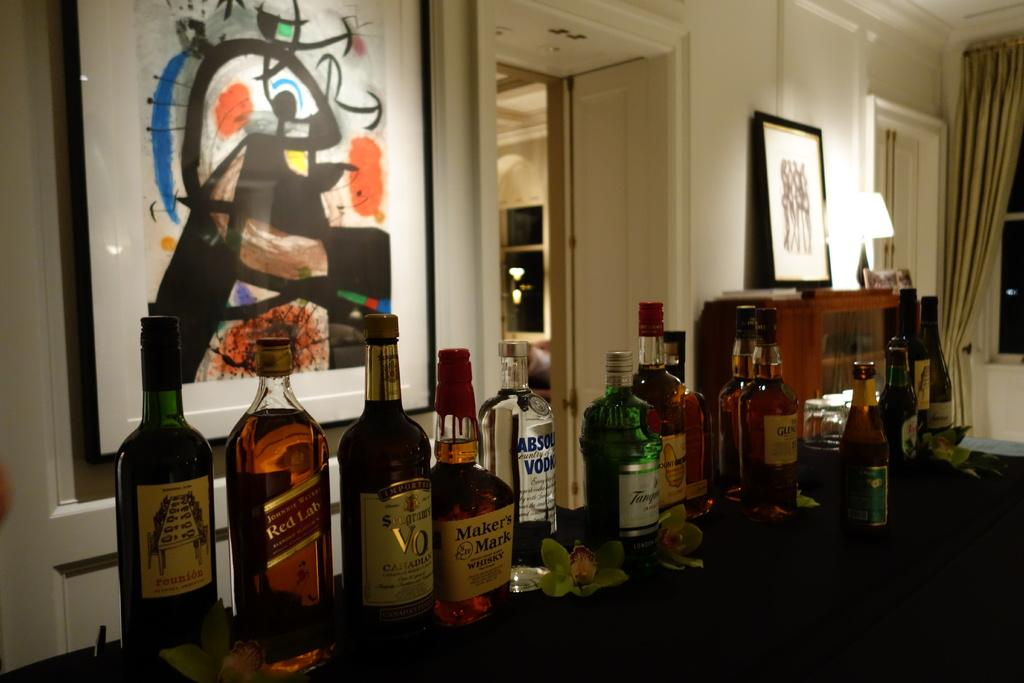<image>
Write a terse but informative summary of the picture. A bottle of Maker's Mark whisky sits on a table with many other bottles. 